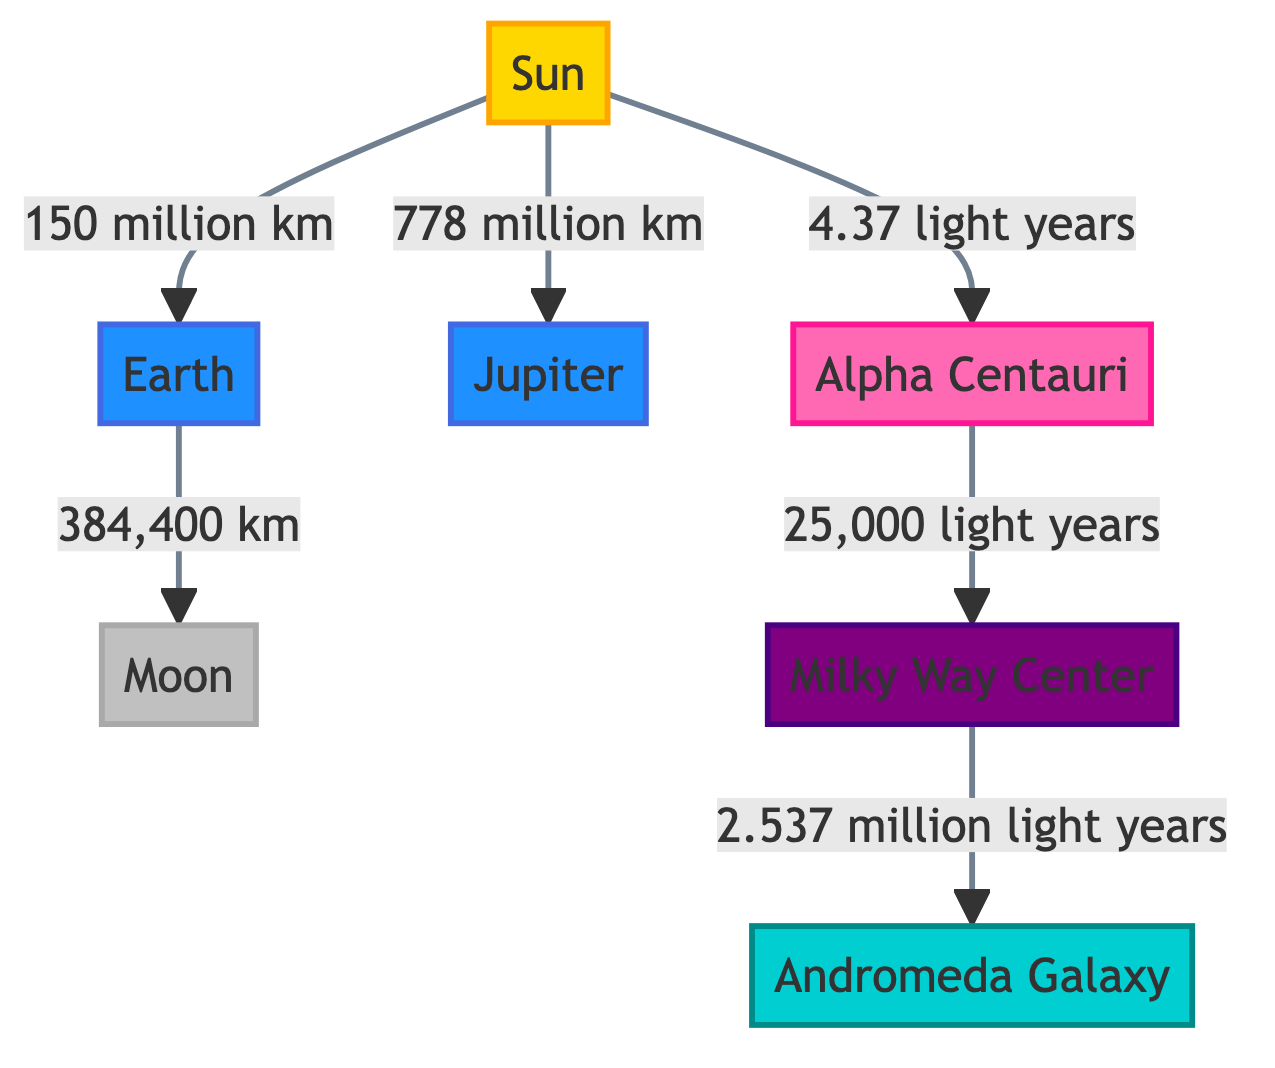What is the distance from the Sun to the Earth? The diagram states that the distance from the Sun to the Earth is 150 million km. This information can be found directly on the edge connecting these two nodes in the diagram.
Answer: 150 million km What celestial object is located 25,000 light years from Alpha Centauri? According to the diagram, Alpha Centauri is connected to the Milky Way Center with a distance of 25,000 light years. Thus, the Milky Way Center is the celestial object located at that distance from Alpha Centauri.
Answer: Milky Way Center How many kilometers is the distance from the Earth to the Moon? The diagram shows that the distance from the Earth to the Moon is 384,400 km. This information is found along the edge connecting the Earth node to the Moon node.
Answer: 384,400 km Which object is closest to the Sun? The Sun is connected directly to the Earth, Moon, and Jupiter. Among these objects, the Earth is the closest to the Sun as indicated by the direct edge between them with a distance.
Answer: Earth What type of celestial object is the Milky Way Center? In the diagram, the Milky Way Center is categorized as a galactic center, which is indicated by its color code and label. The class definition specifies this as a unique category of celestial object.
Answer: Galactic Center What is the distance from the Sun to Alpha Centauri in light years? The diagram states that the distance from the Sun to Alpha Centauri is 4.37 light years. This value is shown along the edge connecting the two nodes.
Answer: 4.37 light years What is the distance from the Milky Way Center to the Andromeda Galaxy? The distance from the Milky Way Center to the Andromeda Galaxy is stated in the diagram as 2.537 million light years. This is clearly marked along the edge linking these two nodes.
Answer: 2.537 million light years How many distinct celestial objects are represented in this diagram? The diagram includes seven distinct celestial objects: the Sun, Earth, Moon, Jupiter, Alpha Centauri, Milky Way Center, and Andromeda Galaxy. Counting each labeled node gives us the total.
Answer: 7 What celestial object is represented in purple? In the diagram, the Milky Way Center is colored purple, which corresponds to the class definition for galactic center. The color coding directly indicates its classification.
Answer: Milky Way Center 